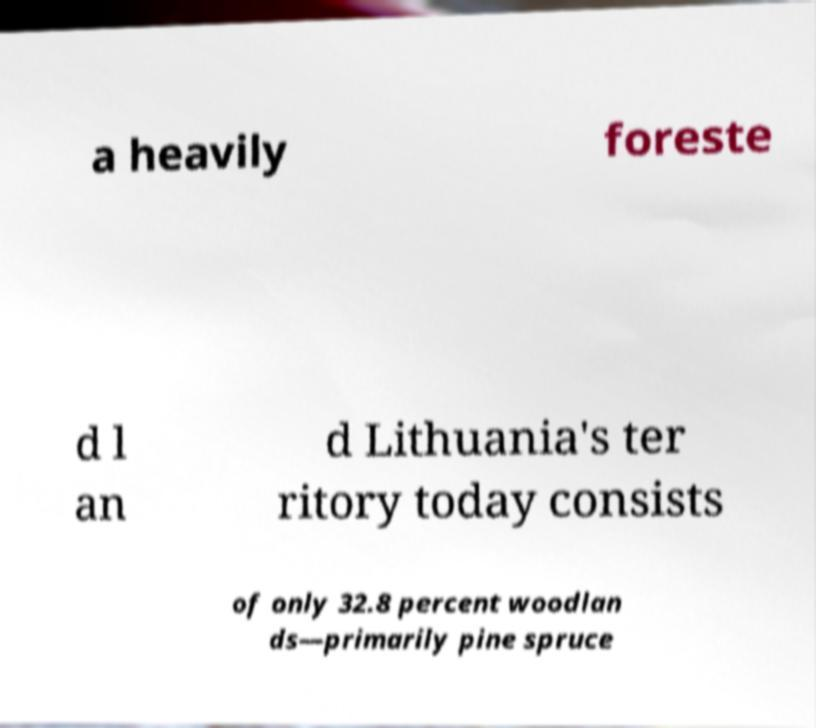There's text embedded in this image that I need extracted. Can you transcribe it verbatim? a heavily foreste d l an d Lithuania's ter ritory today consists of only 32.8 percent woodlan ds—primarily pine spruce 